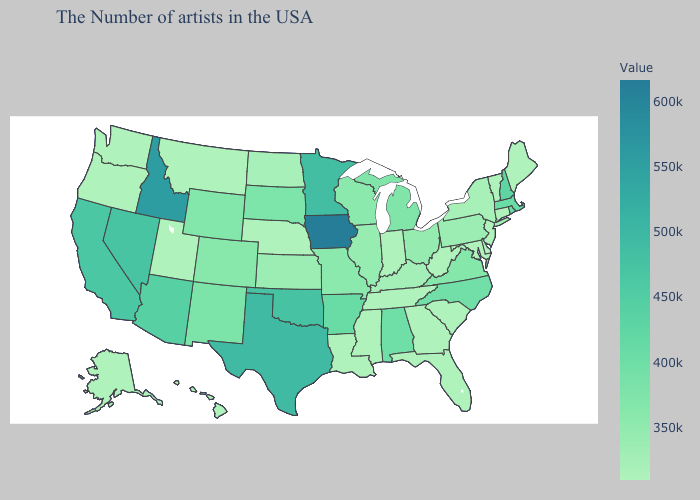Which states have the highest value in the USA?
Short answer required. Iowa. Does Nebraska have a higher value than Massachusetts?
Quick response, please. No. Among the states that border Wisconsin , which have the lowest value?
Give a very brief answer. Illinois. Does the map have missing data?
Answer briefly. No. Does the map have missing data?
Answer briefly. No. Which states have the lowest value in the USA?
Concise answer only. Maine, Vermont, Connecticut, New Jersey, Delaware, Maryland, South Carolina, West Virginia, Florida, Indiana, Tennessee, Mississippi, Louisiana, Nebraska, Utah, Montana, Washington, Oregon, Alaska, Hawaii. Does Idaho have a lower value than South Carolina?
Quick response, please. No. 